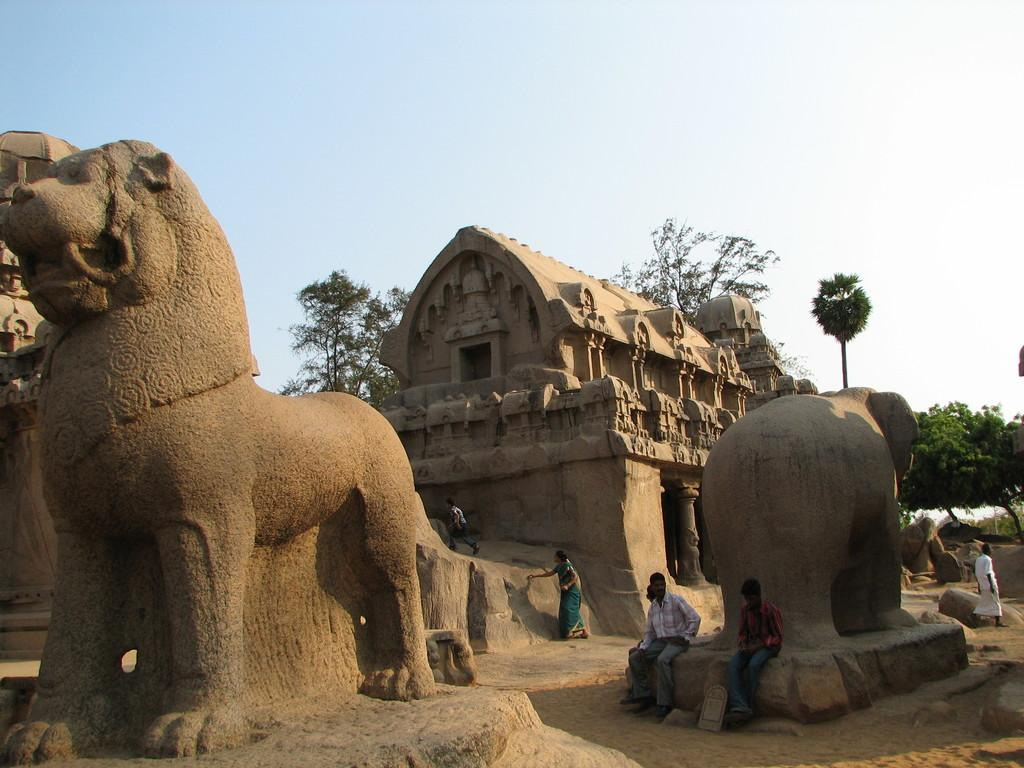What is the main subject of the image? There is a sculpture in the image. Are there any other subjects or objects in the image? Yes, there are people, a building with pillars, trees, and the sky visible in the image. Can you describe the building in the image? The building has pillars. What can be seen in the background of the image? Trees and the sky are visible in the background of the image. What type of line can be seen connecting the sculpture to the building in the image? There is no line connecting the sculpture to the building in the image. 